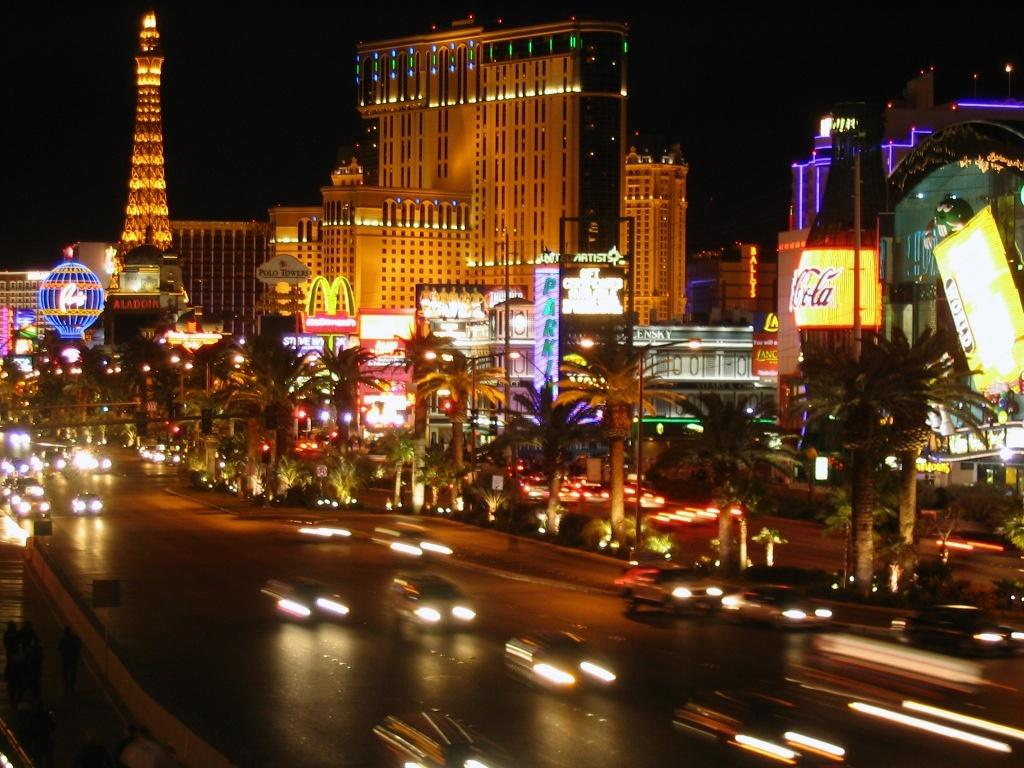What is happening in the image? There are cars on a road in the image. What can be seen in the distance behind the cars? There are trees, buildings, and boards in the background of the image. Are there any visible light sources in the image? Yes, there are lights visible in the image. Where is the father in the image? There is no father present in the image. Is the river mentioned in the image? No, there is no river mentioned or visible in the image. 